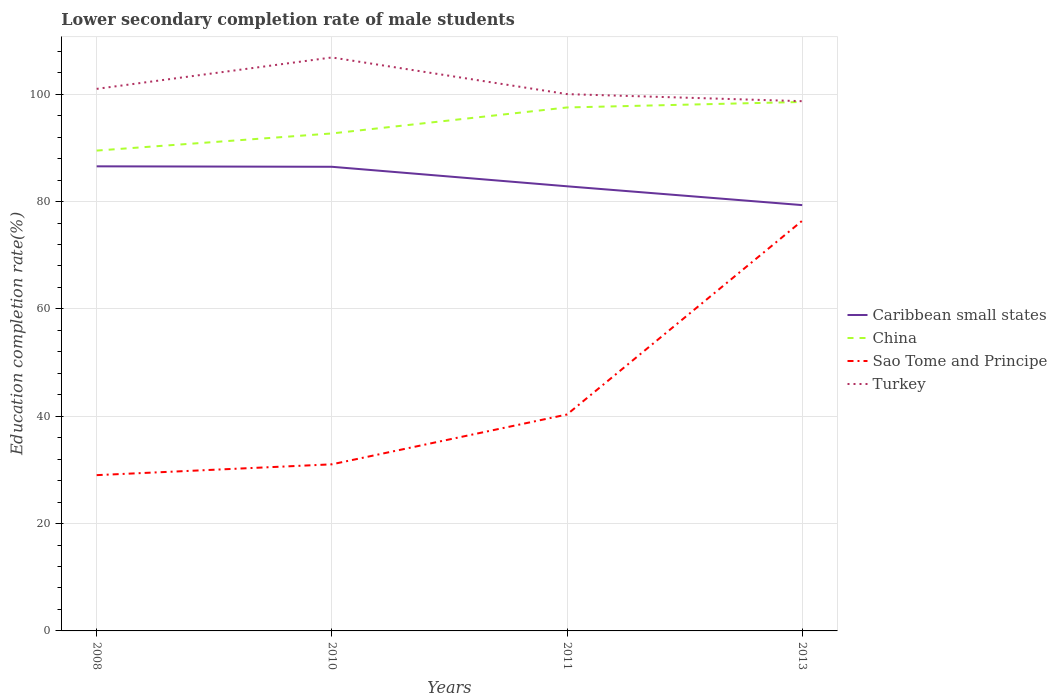How many different coloured lines are there?
Offer a very short reply. 4. Across all years, what is the maximum lower secondary completion rate of male students in China?
Provide a succinct answer. 89.49. In which year was the lower secondary completion rate of male students in China maximum?
Ensure brevity in your answer.  2008. What is the total lower secondary completion rate of male students in Caribbean small states in the graph?
Provide a succinct answer. 3.64. What is the difference between the highest and the second highest lower secondary completion rate of male students in Sao Tome and Principe?
Provide a succinct answer. 47.4. How many lines are there?
Offer a terse response. 4. How many years are there in the graph?
Ensure brevity in your answer.  4. What is the difference between two consecutive major ticks on the Y-axis?
Ensure brevity in your answer.  20. Are the values on the major ticks of Y-axis written in scientific E-notation?
Your answer should be very brief. No. Does the graph contain grids?
Offer a very short reply. Yes. Where does the legend appear in the graph?
Provide a short and direct response. Center right. What is the title of the graph?
Your response must be concise. Lower secondary completion rate of male students. What is the label or title of the X-axis?
Make the answer very short. Years. What is the label or title of the Y-axis?
Provide a short and direct response. Education completion rate(%). What is the Education completion rate(%) in Caribbean small states in 2008?
Offer a terse response. 86.56. What is the Education completion rate(%) in China in 2008?
Offer a very short reply. 89.49. What is the Education completion rate(%) in Sao Tome and Principe in 2008?
Give a very brief answer. 29.03. What is the Education completion rate(%) of Turkey in 2008?
Ensure brevity in your answer.  100.99. What is the Education completion rate(%) of Caribbean small states in 2010?
Your response must be concise. 86.48. What is the Education completion rate(%) of China in 2010?
Make the answer very short. 92.69. What is the Education completion rate(%) of Sao Tome and Principe in 2010?
Make the answer very short. 31.04. What is the Education completion rate(%) in Turkey in 2010?
Your answer should be compact. 106.84. What is the Education completion rate(%) in Caribbean small states in 2011?
Give a very brief answer. 82.84. What is the Education completion rate(%) in China in 2011?
Your answer should be compact. 97.53. What is the Education completion rate(%) in Sao Tome and Principe in 2011?
Make the answer very short. 40.33. What is the Education completion rate(%) in Turkey in 2011?
Give a very brief answer. 100.01. What is the Education completion rate(%) in Caribbean small states in 2013?
Give a very brief answer. 79.33. What is the Education completion rate(%) of China in 2013?
Your response must be concise. 98.56. What is the Education completion rate(%) in Sao Tome and Principe in 2013?
Offer a very short reply. 76.42. What is the Education completion rate(%) in Turkey in 2013?
Offer a terse response. 98.7. Across all years, what is the maximum Education completion rate(%) in Caribbean small states?
Give a very brief answer. 86.56. Across all years, what is the maximum Education completion rate(%) of China?
Make the answer very short. 98.56. Across all years, what is the maximum Education completion rate(%) of Sao Tome and Principe?
Ensure brevity in your answer.  76.42. Across all years, what is the maximum Education completion rate(%) in Turkey?
Ensure brevity in your answer.  106.84. Across all years, what is the minimum Education completion rate(%) in Caribbean small states?
Make the answer very short. 79.33. Across all years, what is the minimum Education completion rate(%) in China?
Your answer should be compact. 89.49. Across all years, what is the minimum Education completion rate(%) of Sao Tome and Principe?
Your answer should be very brief. 29.03. Across all years, what is the minimum Education completion rate(%) in Turkey?
Offer a very short reply. 98.7. What is the total Education completion rate(%) in Caribbean small states in the graph?
Your response must be concise. 335.21. What is the total Education completion rate(%) of China in the graph?
Offer a terse response. 378.27. What is the total Education completion rate(%) of Sao Tome and Principe in the graph?
Your answer should be compact. 176.81. What is the total Education completion rate(%) in Turkey in the graph?
Make the answer very short. 406.55. What is the difference between the Education completion rate(%) of Caribbean small states in 2008 and that in 2010?
Your response must be concise. 0.08. What is the difference between the Education completion rate(%) in China in 2008 and that in 2010?
Provide a succinct answer. -3.19. What is the difference between the Education completion rate(%) in Sao Tome and Principe in 2008 and that in 2010?
Your answer should be compact. -2.01. What is the difference between the Education completion rate(%) of Turkey in 2008 and that in 2010?
Offer a terse response. -5.85. What is the difference between the Education completion rate(%) of Caribbean small states in 2008 and that in 2011?
Your answer should be compact. 3.72. What is the difference between the Education completion rate(%) of China in 2008 and that in 2011?
Offer a very short reply. -8.04. What is the difference between the Education completion rate(%) in Sao Tome and Principe in 2008 and that in 2011?
Your response must be concise. -11.3. What is the difference between the Education completion rate(%) in Turkey in 2008 and that in 2011?
Offer a terse response. 0.98. What is the difference between the Education completion rate(%) of Caribbean small states in 2008 and that in 2013?
Make the answer very short. 7.23. What is the difference between the Education completion rate(%) of China in 2008 and that in 2013?
Provide a succinct answer. -9.06. What is the difference between the Education completion rate(%) in Sao Tome and Principe in 2008 and that in 2013?
Your response must be concise. -47.4. What is the difference between the Education completion rate(%) of Turkey in 2008 and that in 2013?
Give a very brief answer. 2.3. What is the difference between the Education completion rate(%) in Caribbean small states in 2010 and that in 2011?
Give a very brief answer. 3.64. What is the difference between the Education completion rate(%) of China in 2010 and that in 2011?
Your answer should be very brief. -4.84. What is the difference between the Education completion rate(%) of Sao Tome and Principe in 2010 and that in 2011?
Offer a terse response. -9.29. What is the difference between the Education completion rate(%) in Turkey in 2010 and that in 2011?
Keep it short and to the point. 6.83. What is the difference between the Education completion rate(%) in Caribbean small states in 2010 and that in 2013?
Give a very brief answer. 7.14. What is the difference between the Education completion rate(%) of China in 2010 and that in 2013?
Your answer should be very brief. -5.87. What is the difference between the Education completion rate(%) in Sao Tome and Principe in 2010 and that in 2013?
Your answer should be compact. -45.38. What is the difference between the Education completion rate(%) in Turkey in 2010 and that in 2013?
Your answer should be compact. 8.15. What is the difference between the Education completion rate(%) in Caribbean small states in 2011 and that in 2013?
Your answer should be compact. 3.51. What is the difference between the Education completion rate(%) in China in 2011 and that in 2013?
Offer a very short reply. -1.03. What is the difference between the Education completion rate(%) of Sao Tome and Principe in 2011 and that in 2013?
Your answer should be very brief. -36.1. What is the difference between the Education completion rate(%) in Turkey in 2011 and that in 2013?
Ensure brevity in your answer.  1.32. What is the difference between the Education completion rate(%) of Caribbean small states in 2008 and the Education completion rate(%) of China in 2010?
Offer a terse response. -6.13. What is the difference between the Education completion rate(%) of Caribbean small states in 2008 and the Education completion rate(%) of Sao Tome and Principe in 2010?
Ensure brevity in your answer.  55.52. What is the difference between the Education completion rate(%) in Caribbean small states in 2008 and the Education completion rate(%) in Turkey in 2010?
Make the answer very short. -20.28. What is the difference between the Education completion rate(%) in China in 2008 and the Education completion rate(%) in Sao Tome and Principe in 2010?
Keep it short and to the point. 58.45. What is the difference between the Education completion rate(%) of China in 2008 and the Education completion rate(%) of Turkey in 2010?
Keep it short and to the point. -17.35. What is the difference between the Education completion rate(%) in Sao Tome and Principe in 2008 and the Education completion rate(%) in Turkey in 2010?
Ensure brevity in your answer.  -77.82. What is the difference between the Education completion rate(%) of Caribbean small states in 2008 and the Education completion rate(%) of China in 2011?
Ensure brevity in your answer.  -10.97. What is the difference between the Education completion rate(%) in Caribbean small states in 2008 and the Education completion rate(%) in Sao Tome and Principe in 2011?
Your response must be concise. 46.24. What is the difference between the Education completion rate(%) in Caribbean small states in 2008 and the Education completion rate(%) in Turkey in 2011?
Provide a succinct answer. -13.45. What is the difference between the Education completion rate(%) of China in 2008 and the Education completion rate(%) of Sao Tome and Principe in 2011?
Offer a very short reply. 49.17. What is the difference between the Education completion rate(%) of China in 2008 and the Education completion rate(%) of Turkey in 2011?
Provide a succinct answer. -10.52. What is the difference between the Education completion rate(%) in Sao Tome and Principe in 2008 and the Education completion rate(%) in Turkey in 2011?
Your answer should be very brief. -70.99. What is the difference between the Education completion rate(%) in Caribbean small states in 2008 and the Education completion rate(%) in China in 2013?
Offer a terse response. -12. What is the difference between the Education completion rate(%) of Caribbean small states in 2008 and the Education completion rate(%) of Sao Tome and Principe in 2013?
Ensure brevity in your answer.  10.14. What is the difference between the Education completion rate(%) in Caribbean small states in 2008 and the Education completion rate(%) in Turkey in 2013?
Provide a short and direct response. -12.14. What is the difference between the Education completion rate(%) in China in 2008 and the Education completion rate(%) in Sao Tome and Principe in 2013?
Offer a very short reply. 13.07. What is the difference between the Education completion rate(%) of China in 2008 and the Education completion rate(%) of Turkey in 2013?
Keep it short and to the point. -9.2. What is the difference between the Education completion rate(%) in Sao Tome and Principe in 2008 and the Education completion rate(%) in Turkey in 2013?
Your answer should be compact. -69.67. What is the difference between the Education completion rate(%) of Caribbean small states in 2010 and the Education completion rate(%) of China in 2011?
Provide a succinct answer. -11.05. What is the difference between the Education completion rate(%) in Caribbean small states in 2010 and the Education completion rate(%) in Sao Tome and Principe in 2011?
Your response must be concise. 46.15. What is the difference between the Education completion rate(%) in Caribbean small states in 2010 and the Education completion rate(%) in Turkey in 2011?
Provide a succinct answer. -13.54. What is the difference between the Education completion rate(%) of China in 2010 and the Education completion rate(%) of Sao Tome and Principe in 2011?
Your answer should be very brief. 52.36. What is the difference between the Education completion rate(%) of China in 2010 and the Education completion rate(%) of Turkey in 2011?
Offer a very short reply. -7.33. What is the difference between the Education completion rate(%) in Sao Tome and Principe in 2010 and the Education completion rate(%) in Turkey in 2011?
Keep it short and to the point. -68.97. What is the difference between the Education completion rate(%) of Caribbean small states in 2010 and the Education completion rate(%) of China in 2013?
Make the answer very short. -12.08. What is the difference between the Education completion rate(%) in Caribbean small states in 2010 and the Education completion rate(%) in Sao Tome and Principe in 2013?
Offer a very short reply. 10.05. What is the difference between the Education completion rate(%) in Caribbean small states in 2010 and the Education completion rate(%) in Turkey in 2013?
Offer a terse response. -12.22. What is the difference between the Education completion rate(%) of China in 2010 and the Education completion rate(%) of Sao Tome and Principe in 2013?
Your answer should be compact. 16.27. What is the difference between the Education completion rate(%) of China in 2010 and the Education completion rate(%) of Turkey in 2013?
Your answer should be compact. -6.01. What is the difference between the Education completion rate(%) in Sao Tome and Principe in 2010 and the Education completion rate(%) in Turkey in 2013?
Provide a short and direct response. -67.66. What is the difference between the Education completion rate(%) in Caribbean small states in 2011 and the Education completion rate(%) in China in 2013?
Offer a terse response. -15.71. What is the difference between the Education completion rate(%) of Caribbean small states in 2011 and the Education completion rate(%) of Sao Tome and Principe in 2013?
Your response must be concise. 6.42. What is the difference between the Education completion rate(%) in Caribbean small states in 2011 and the Education completion rate(%) in Turkey in 2013?
Make the answer very short. -15.86. What is the difference between the Education completion rate(%) in China in 2011 and the Education completion rate(%) in Sao Tome and Principe in 2013?
Keep it short and to the point. 21.11. What is the difference between the Education completion rate(%) in China in 2011 and the Education completion rate(%) in Turkey in 2013?
Ensure brevity in your answer.  -1.17. What is the difference between the Education completion rate(%) in Sao Tome and Principe in 2011 and the Education completion rate(%) in Turkey in 2013?
Provide a succinct answer. -58.37. What is the average Education completion rate(%) of Caribbean small states per year?
Provide a succinct answer. 83.8. What is the average Education completion rate(%) in China per year?
Offer a terse response. 94.57. What is the average Education completion rate(%) in Sao Tome and Principe per year?
Provide a succinct answer. 44.2. What is the average Education completion rate(%) of Turkey per year?
Give a very brief answer. 101.64. In the year 2008, what is the difference between the Education completion rate(%) of Caribbean small states and Education completion rate(%) of China?
Make the answer very short. -2.93. In the year 2008, what is the difference between the Education completion rate(%) in Caribbean small states and Education completion rate(%) in Sao Tome and Principe?
Make the answer very short. 57.54. In the year 2008, what is the difference between the Education completion rate(%) of Caribbean small states and Education completion rate(%) of Turkey?
Offer a terse response. -14.43. In the year 2008, what is the difference between the Education completion rate(%) of China and Education completion rate(%) of Sao Tome and Principe?
Keep it short and to the point. 60.47. In the year 2008, what is the difference between the Education completion rate(%) of China and Education completion rate(%) of Turkey?
Your response must be concise. -11.5. In the year 2008, what is the difference between the Education completion rate(%) in Sao Tome and Principe and Education completion rate(%) in Turkey?
Offer a terse response. -71.97. In the year 2010, what is the difference between the Education completion rate(%) of Caribbean small states and Education completion rate(%) of China?
Offer a terse response. -6.21. In the year 2010, what is the difference between the Education completion rate(%) of Caribbean small states and Education completion rate(%) of Sao Tome and Principe?
Offer a very short reply. 55.44. In the year 2010, what is the difference between the Education completion rate(%) in Caribbean small states and Education completion rate(%) in Turkey?
Your answer should be very brief. -20.37. In the year 2010, what is the difference between the Education completion rate(%) of China and Education completion rate(%) of Sao Tome and Principe?
Ensure brevity in your answer.  61.65. In the year 2010, what is the difference between the Education completion rate(%) in China and Education completion rate(%) in Turkey?
Provide a short and direct response. -14.16. In the year 2010, what is the difference between the Education completion rate(%) in Sao Tome and Principe and Education completion rate(%) in Turkey?
Your response must be concise. -75.81. In the year 2011, what is the difference between the Education completion rate(%) of Caribbean small states and Education completion rate(%) of China?
Offer a very short reply. -14.69. In the year 2011, what is the difference between the Education completion rate(%) in Caribbean small states and Education completion rate(%) in Sao Tome and Principe?
Give a very brief answer. 42.52. In the year 2011, what is the difference between the Education completion rate(%) in Caribbean small states and Education completion rate(%) in Turkey?
Ensure brevity in your answer.  -17.17. In the year 2011, what is the difference between the Education completion rate(%) of China and Education completion rate(%) of Sao Tome and Principe?
Your response must be concise. 57.21. In the year 2011, what is the difference between the Education completion rate(%) of China and Education completion rate(%) of Turkey?
Offer a very short reply. -2.48. In the year 2011, what is the difference between the Education completion rate(%) of Sao Tome and Principe and Education completion rate(%) of Turkey?
Keep it short and to the point. -59.69. In the year 2013, what is the difference between the Education completion rate(%) of Caribbean small states and Education completion rate(%) of China?
Provide a short and direct response. -19.22. In the year 2013, what is the difference between the Education completion rate(%) in Caribbean small states and Education completion rate(%) in Sao Tome and Principe?
Keep it short and to the point. 2.91. In the year 2013, what is the difference between the Education completion rate(%) in Caribbean small states and Education completion rate(%) in Turkey?
Keep it short and to the point. -19.36. In the year 2013, what is the difference between the Education completion rate(%) in China and Education completion rate(%) in Sao Tome and Principe?
Make the answer very short. 22.13. In the year 2013, what is the difference between the Education completion rate(%) in China and Education completion rate(%) in Turkey?
Provide a short and direct response. -0.14. In the year 2013, what is the difference between the Education completion rate(%) of Sao Tome and Principe and Education completion rate(%) of Turkey?
Ensure brevity in your answer.  -22.27. What is the ratio of the Education completion rate(%) of Caribbean small states in 2008 to that in 2010?
Offer a very short reply. 1. What is the ratio of the Education completion rate(%) in China in 2008 to that in 2010?
Keep it short and to the point. 0.97. What is the ratio of the Education completion rate(%) in Sao Tome and Principe in 2008 to that in 2010?
Your response must be concise. 0.94. What is the ratio of the Education completion rate(%) in Turkey in 2008 to that in 2010?
Your response must be concise. 0.95. What is the ratio of the Education completion rate(%) of Caribbean small states in 2008 to that in 2011?
Make the answer very short. 1.04. What is the ratio of the Education completion rate(%) in China in 2008 to that in 2011?
Your answer should be very brief. 0.92. What is the ratio of the Education completion rate(%) of Sao Tome and Principe in 2008 to that in 2011?
Your response must be concise. 0.72. What is the ratio of the Education completion rate(%) in Turkey in 2008 to that in 2011?
Your answer should be very brief. 1.01. What is the ratio of the Education completion rate(%) in Caribbean small states in 2008 to that in 2013?
Give a very brief answer. 1.09. What is the ratio of the Education completion rate(%) in China in 2008 to that in 2013?
Your answer should be very brief. 0.91. What is the ratio of the Education completion rate(%) in Sao Tome and Principe in 2008 to that in 2013?
Provide a succinct answer. 0.38. What is the ratio of the Education completion rate(%) of Turkey in 2008 to that in 2013?
Your response must be concise. 1.02. What is the ratio of the Education completion rate(%) in Caribbean small states in 2010 to that in 2011?
Give a very brief answer. 1.04. What is the ratio of the Education completion rate(%) of China in 2010 to that in 2011?
Provide a succinct answer. 0.95. What is the ratio of the Education completion rate(%) of Sao Tome and Principe in 2010 to that in 2011?
Make the answer very short. 0.77. What is the ratio of the Education completion rate(%) of Turkey in 2010 to that in 2011?
Your response must be concise. 1.07. What is the ratio of the Education completion rate(%) of Caribbean small states in 2010 to that in 2013?
Make the answer very short. 1.09. What is the ratio of the Education completion rate(%) in China in 2010 to that in 2013?
Provide a succinct answer. 0.94. What is the ratio of the Education completion rate(%) of Sao Tome and Principe in 2010 to that in 2013?
Provide a succinct answer. 0.41. What is the ratio of the Education completion rate(%) in Turkey in 2010 to that in 2013?
Your response must be concise. 1.08. What is the ratio of the Education completion rate(%) of Caribbean small states in 2011 to that in 2013?
Give a very brief answer. 1.04. What is the ratio of the Education completion rate(%) in China in 2011 to that in 2013?
Offer a terse response. 0.99. What is the ratio of the Education completion rate(%) in Sao Tome and Principe in 2011 to that in 2013?
Provide a short and direct response. 0.53. What is the ratio of the Education completion rate(%) in Turkey in 2011 to that in 2013?
Keep it short and to the point. 1.01. What is the difference between the highest and the second highest Education completion rate(%) of Caribbean small states?
Give a very brief answer. 0.08. What is the difference between the highest and the second highest Education completion rate(%) in China?
Provide a succinct answer. 1.03. What is the difference between the highest and the second highest Education completion rate(%) in Sao Tome and Principe?
Ensure brevity in your answer.  36.1. What is the difference between the highest and the second highest Education completion rate(%) of Turkey?
Your answer should be compact. 5.85. What is the difference between the highest and the lowest Education completion rate(%) of Caribbean small states?
Keep it short and to the point. 7.23. What is the difference between the highest and the lowest Education completion rate(%) of China?
Provide a succinct answer. 9.06. What is the difference between the highest and the lowest Education completion rate(%) in Sao Tome and Principe?
Keep it short and to the point. 47.4. What is the difference between the highest and the lowest Education completion rate(%) of Turkey?
Your response must be concise. 8.15. 